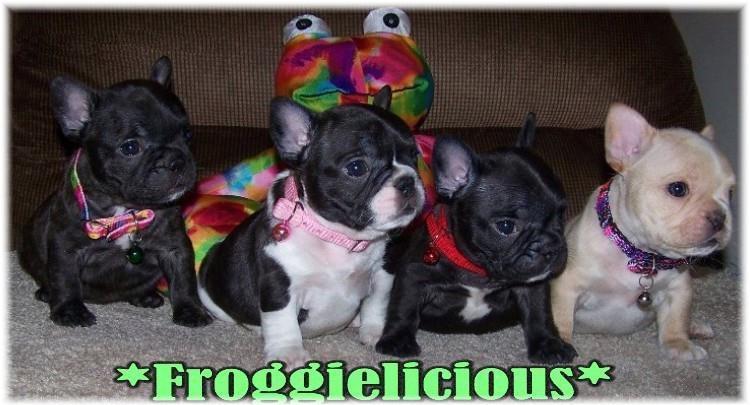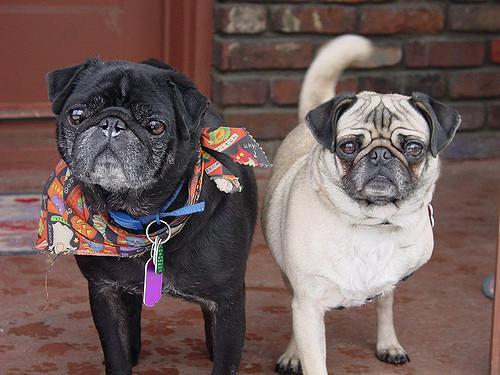The first image is the image on the left, the second image is the image on the right. Examine the images to the left and right. Is the description "There is an image with no more and no less than two dogs." accurate? Answer yes or no. Yes. 